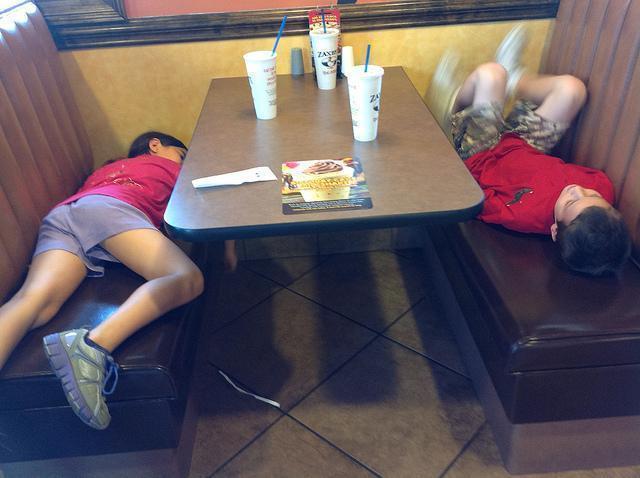Who will pay for this meal?
From the following set of four choices, select the accurate answer to respond to the question.
Options: Parent, no one, child rightmost, leftmost child. Parent. 